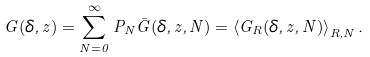Convert formula to latex. <formula><loc_0><loc_0><loc_500><loc_500>G ( \delta , z ) = \sum ^ { \infty } _ { N = 0 } P _ { N } \bar { G } ( \delta , z , N ) = \left < G _ { R } ( \delta , z , N ) \right > _ { R , N } .</formula> 